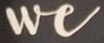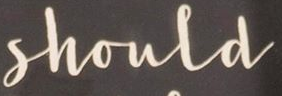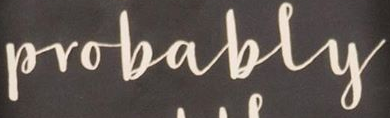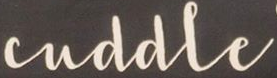What words are shown in these images in order, separated by a semicolon? We; Shoula; Probably; cuddle 